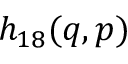Convert formula to latex. <formula><loc_0><loc_0><loc_500><loc_500>h _ { 1 8 } ( q , p )</formula> 